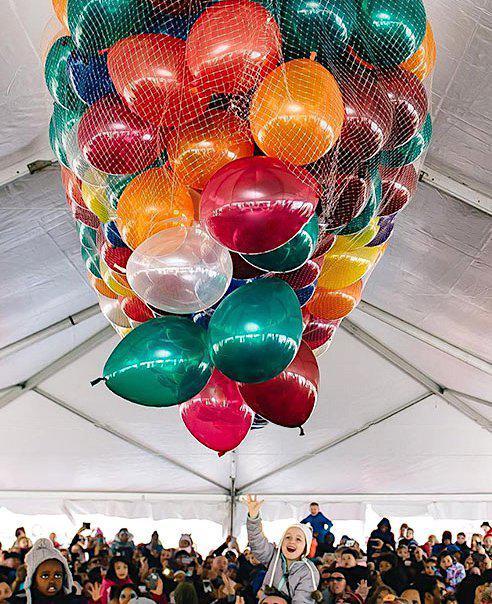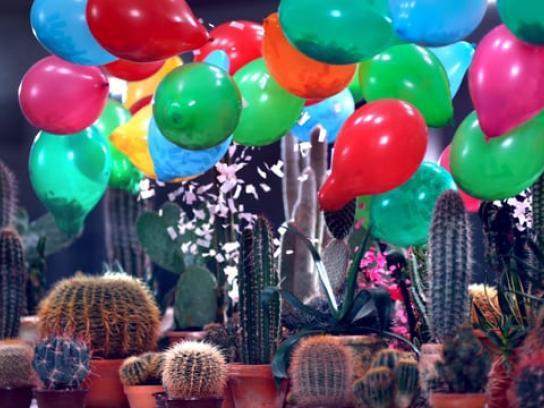The first image is the image on the left, the second image is the image on the right. For the images shown, is this caption "There are solid red balloons in the right image, and green balloons in the left." true? Answer yes or no. Yes. 